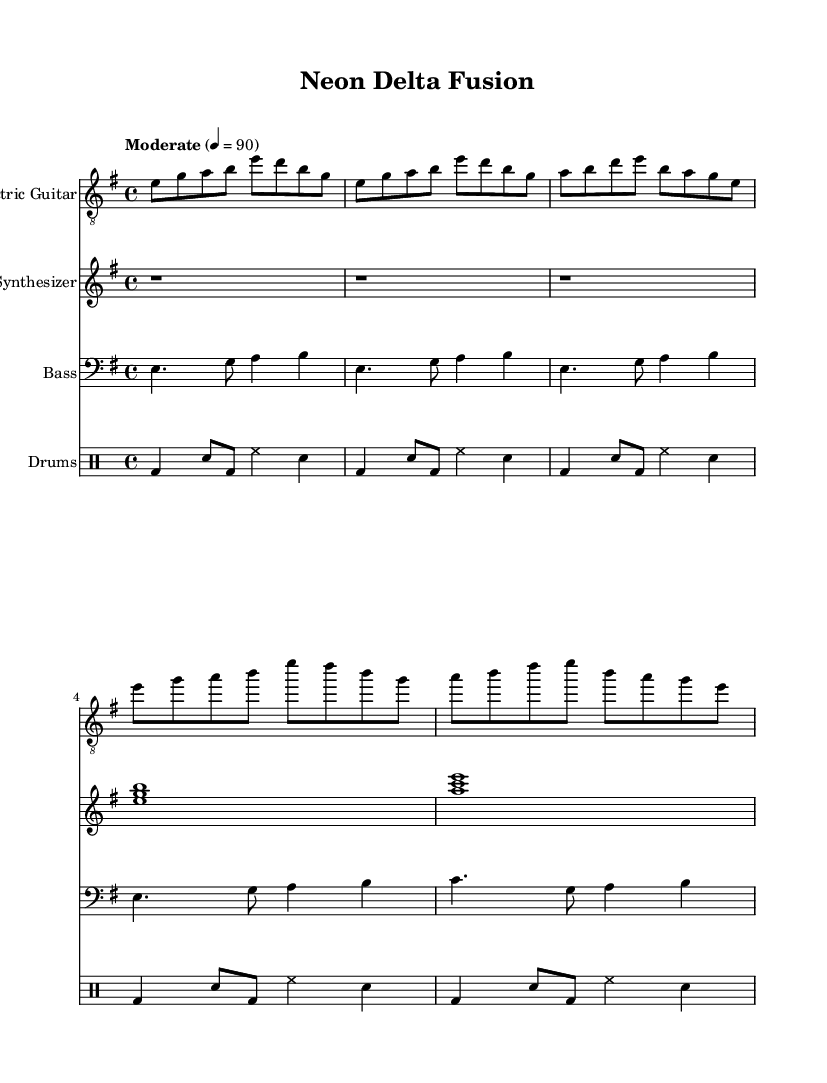What is the key signature of this music? The key signature is E minor, which has one sharp (F#).
Answer: E minor What is the time signature of this music? The time signature indicated in the music is 4/4, meaning there are four beats in each measure.
Answer: 4/4 What is the tempo marking of the piece? The tempo marking indicates "Moderate" with a metronome marking of 90 beats per minute.
Answer: 90 How many measures are in the chorus section? By counting the measures within the chorus section, there are a total of four measures.
Answer: 4 What is the primary instrument featured in this score? The score primarily features the Electric Guitar, as indicated at the top of the first staff.
Answer: Electric Guitar What type of rhythm does the drums use in the intro? The drums feature a kick-snare pattern followed by hi-hat on the fourth beat, reflecting a basic rock rhythm which is common in electric blues.
Answer: Kick-snare pattern How does the bass interact with the electric guitar in the verse? The bass plays a complementary role to the electric guitar by providing a rhythmic and harmonic foundation, maintaining a consistent flow while following the chord changes.
Answer: Complementary role 